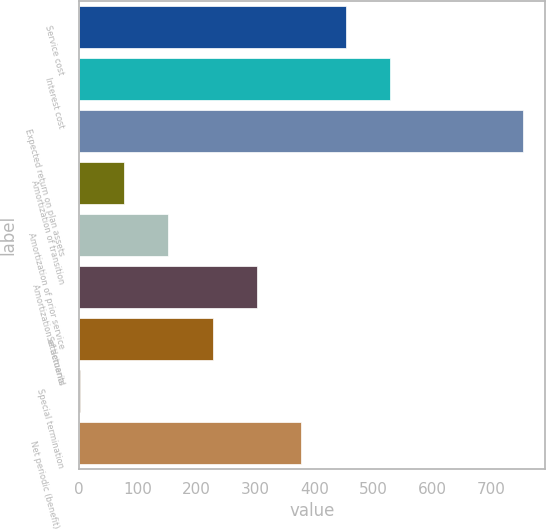Convert chart. <chart><loc_0><loc_0><loc_500><loc_500><bar_chart><fcel>Service cost<fcel>Interest cost<fcel>Expected return on plan assets<fcel>Amortization of transition<fcel>Amortization of prior service<fcel>Amortization of actuarial<fcel>Settlements<fcel>Special termination<fcel>Net periodic (benefit) cost<nl><fcel>453.2<fcel>528.4<fcel>754<fcel>77.2<fcel>152.4<fcel>302.8<fcel>227.6<fcel>2<fcel>378<nl></chart> 